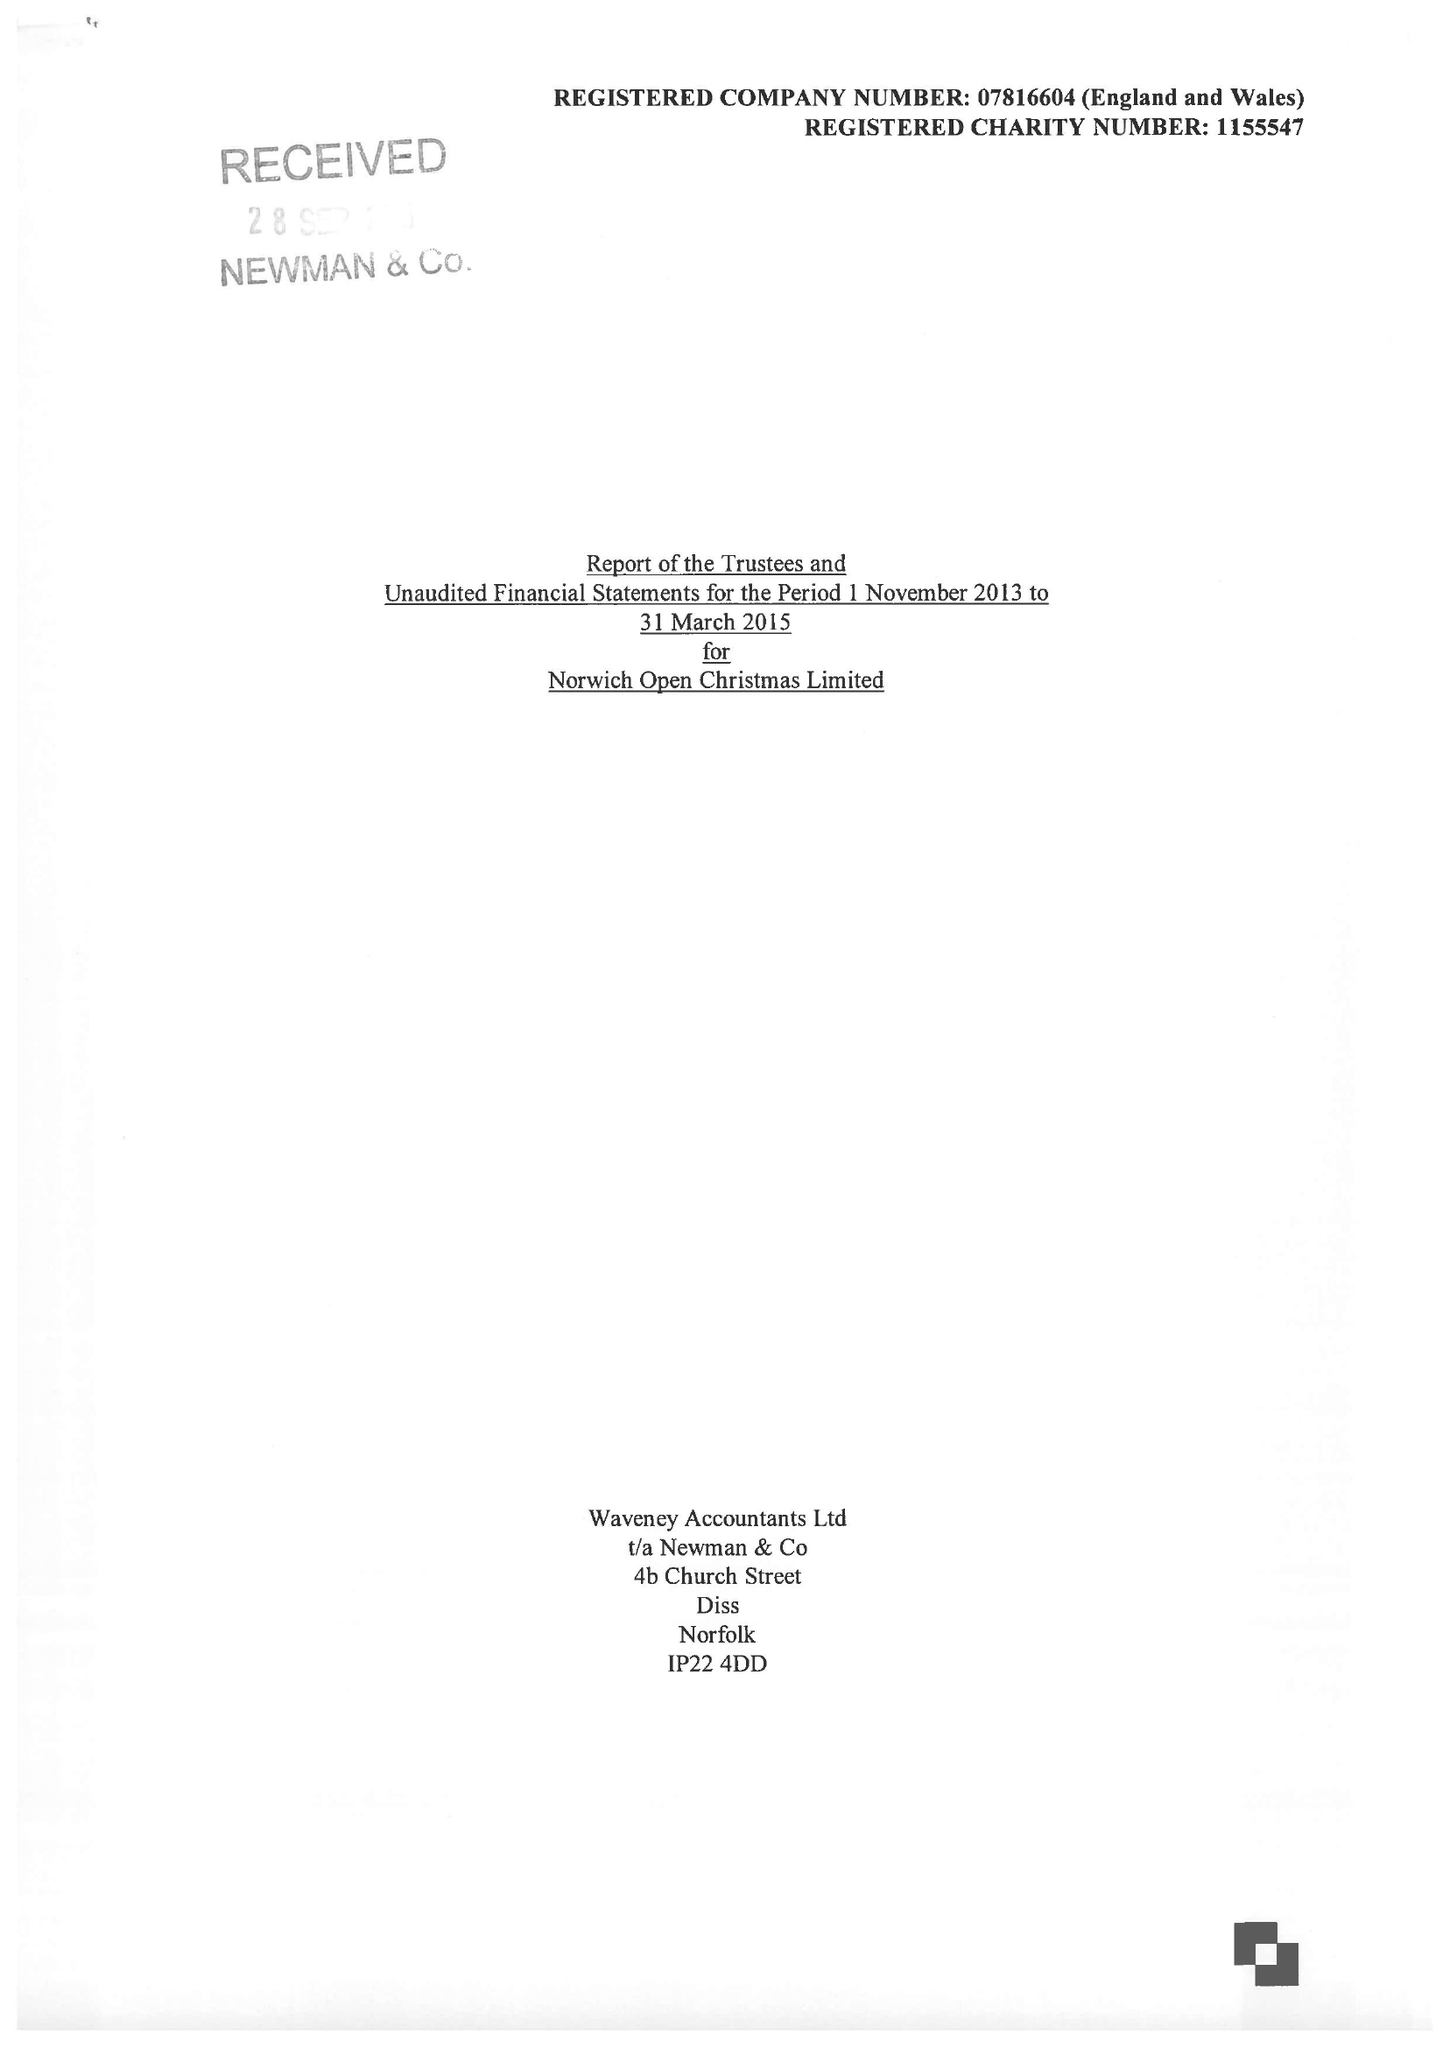What is the value for the charity_number?
Answer the question using a single word or phrase. 1155547 